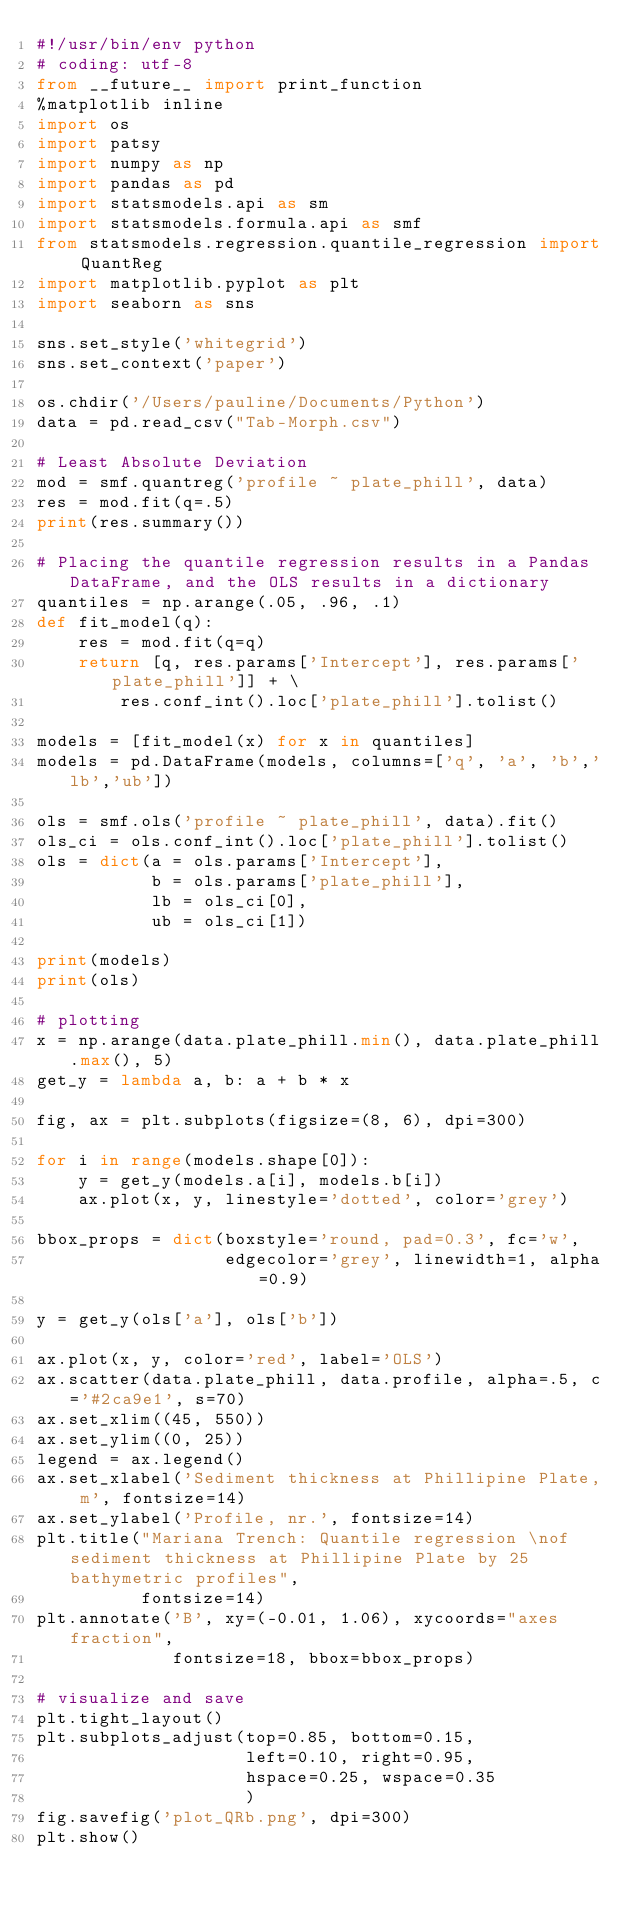Convert code to text. <code><loc_0><loc_0><loc_500><loc_500><_Python_>#!/usr/bin/env python
# coding: utf-8
from __future__ import print_function
%matplotlib inline
import os
import patsy
import numpy as np
import pandas as pd
import statsmodels.api as sm
import statsmodels.formula.api as smf
from statsmodels.regression.quantile_regression import QuantReg
import matplotlib.pyplot as plt
import seaborn as sns

sns.set_style('whitegrid')
sns.set_context('paper')

os.chdir('/Users/pauline/Documents/Python')
data = pd.read_csv("Tab-Morph.csv")

# Least Absolute Deviation
mod = smf.quantreg('profile ~ plate_phill', data)
res = mod.fit(q=.5)
print(res.summary())

# Placing the quantile regression results in a Pandas DataFrame, and the OLS results in a dictionary
quantiles = np.arange(.05, .96, .1)
def fit_model(q):
    res = mod.fit(q=q)
    return [q, res.params['Intercept'], res.params['plate_phill']] + \
        res.conf_int().loc['plate_phill'].tolist()

models = [fit_model(x) for x in quantiles]
models = pd.DataFrame(models, columns=['q', 'a', 'b','lb','ub'])

ols = smf.ols('profile ~ plate_phill', data).fit()
ols_ci = ols.conf_int().loc['plate_phill'].tolist()
ols = dict(a = ols.params['Intercept'],
           b = ols.params['plate_phill'],
           lb = ols_ci[0],
           ub = ols_ci[1])

print(models)
print(ols)

# plotting
x = np.arange(data.plate_phill.min(), data.plate_phill.max(), 5)
get_y = lambda a, b: a + b * x

fig, ax = plt.subplots(figsize=(8, 6), dpi=300)

for i in range(models.shape[0]):
    y = get_y(models.a[i], models.b[i])
    ax.plot(x, y, linestyle='dotted', color='grey')

bbox_props = dict(boxstyle='round, pad=0.3', fc='w',
                  edgecolor='grey', linewidth=1, alpha=0.9)

y = get_y(ols['a'], ols['b'])

ax.plot(x, y, color='red', label='OLS')
ax.scatter(data.plate_phill, data.profile, alpha=.5, c='#2ca9e1', s=70)
ax.set_xlim((45, 550))
ax.set_ylim((0, 25))
legend = ax.legend()
ax.set_xlabel('Sediment thickness at Phillipine Plate, m', fontsize=14)
ax.set_ylabel('Profile, nr.', fontsize=14)
plt.title("Mariana Trench: Quantile regression \nof sediment thickness at Phillipine Plate by 25 bathymetric profiles",
          fontsize=14)
plt.annotate('B', xy=(-0.01, 1.06), xycoords="axes fraction",
             fontsize=18, bbox=bbox_props)

# visualize and save
plt.tight_layout()
plt.subplots_adjust(top=0.85, bottom=0.15,
                    left=0.10, right=0.95,
                    hspace=0.25, wspace=0.35
                    )
fig.savefig('plot_QRb.png', dpi=300)
plt.show()
</code> 